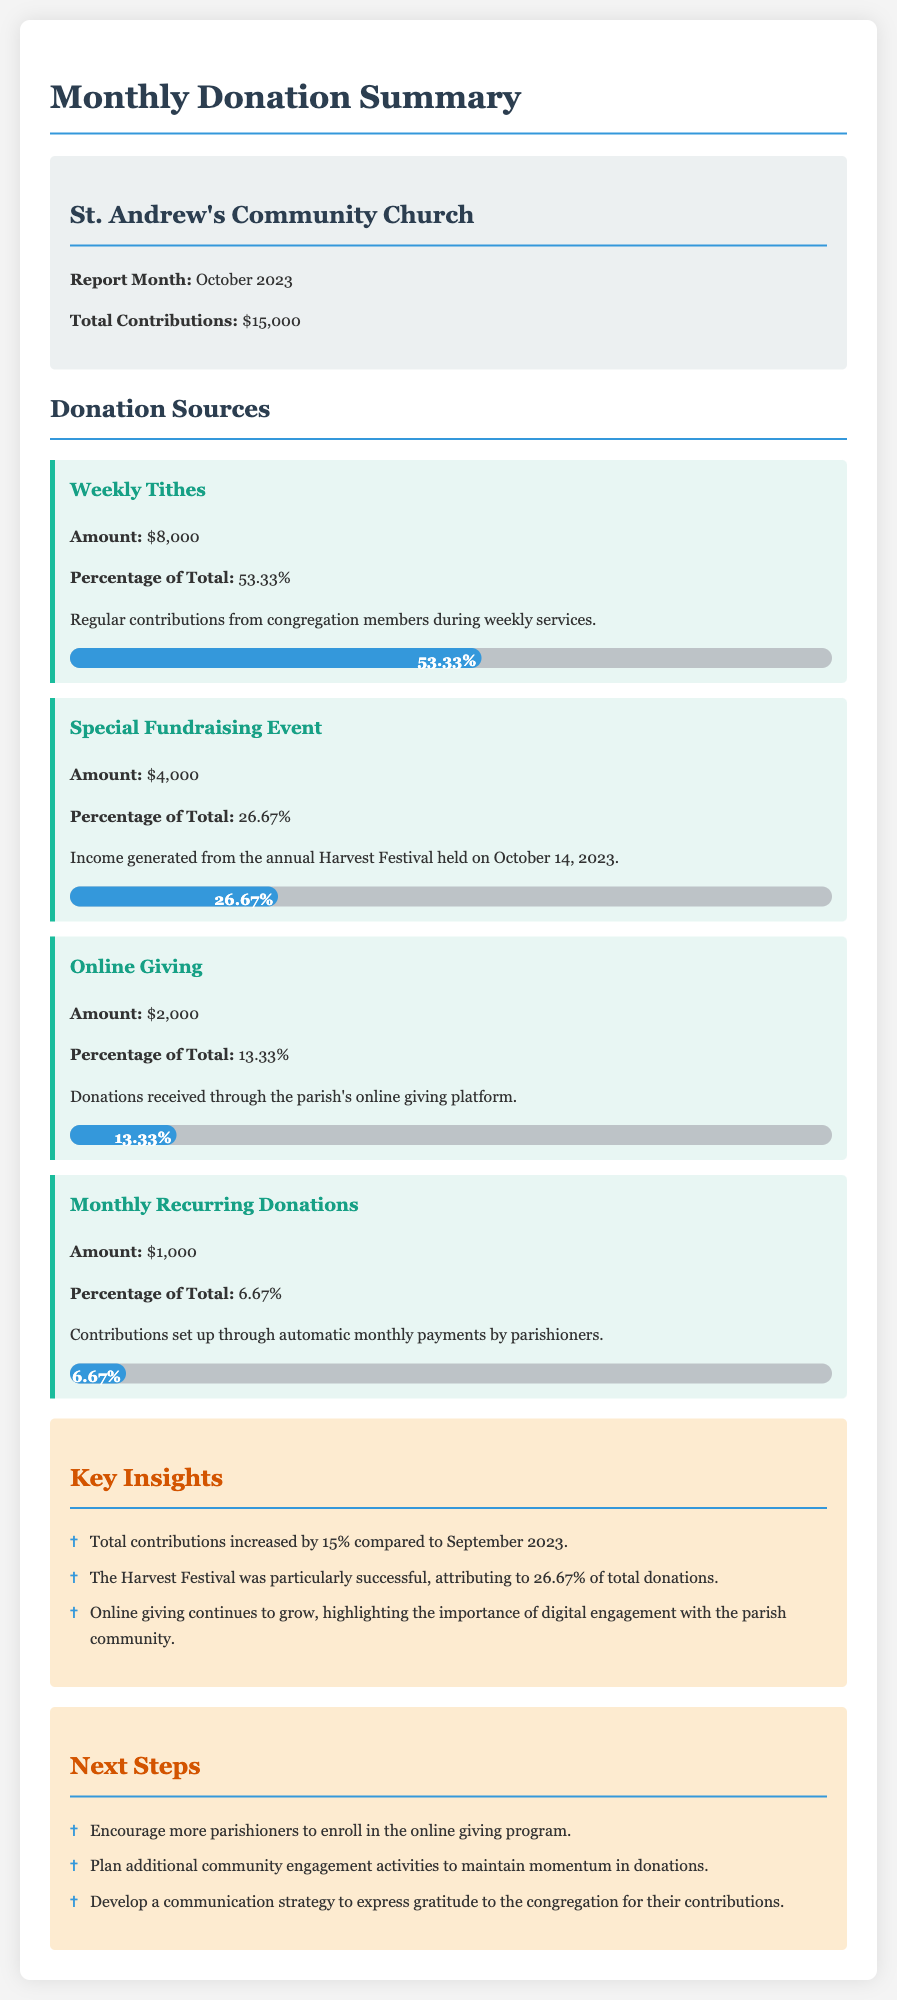What is the report month? The report month is stated as the month for which the donations are being summarized in the document.
Answer: October 2023 What is the total contribution for October 2023? The total contribution is specifically mentioned in the summary section of the document.
Answer: $15,000 How much was raised through Weekly Tithes? The amount raised through Weekly Tithes is explicitly stated in the donation sources section of the document.
Answer: $8,000 What percentage of total donations came from the Special Fundraising Event? The document provides the percentage attributed to the Special Fundraising Event in relation to the total contributions.
Answer: 26.67% What was the increase in total contributions compared to September 2023? The key insight section mentions how much the total contributions increased in percentage compared to the previous month.
Answer: 15% What is one of the next steps mentioned in the report? The next steps section includes specific actions the parish plans to take to improve donations.
Answer: Encourage more parishioners to enroll in the online giving program What source contributed the least to the total donations? The sources are outlined by amount, and we need to find which one is the lowest.
Answer: Monthly Recurring Donations What was the income from Online Giving? The income generated from Online Giving is clearly listed in the detailed breakdown of donations.
Answer: $2,000 What key event contributed significantly to this month’s donations? The key insight section highlights a specific event that had a significant impact on the donations for the month.
Answer: Harvest Festival 